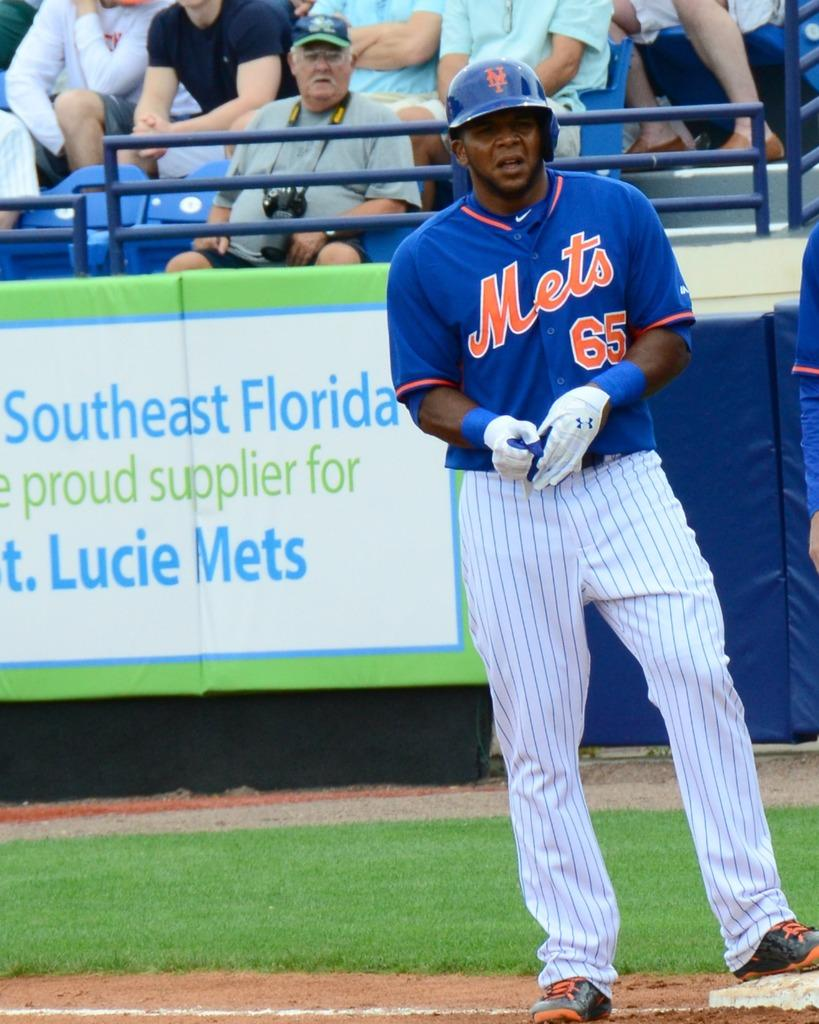Provide a one-sentence caption for the provided image. A baseball player in a blue Mets uniform. 